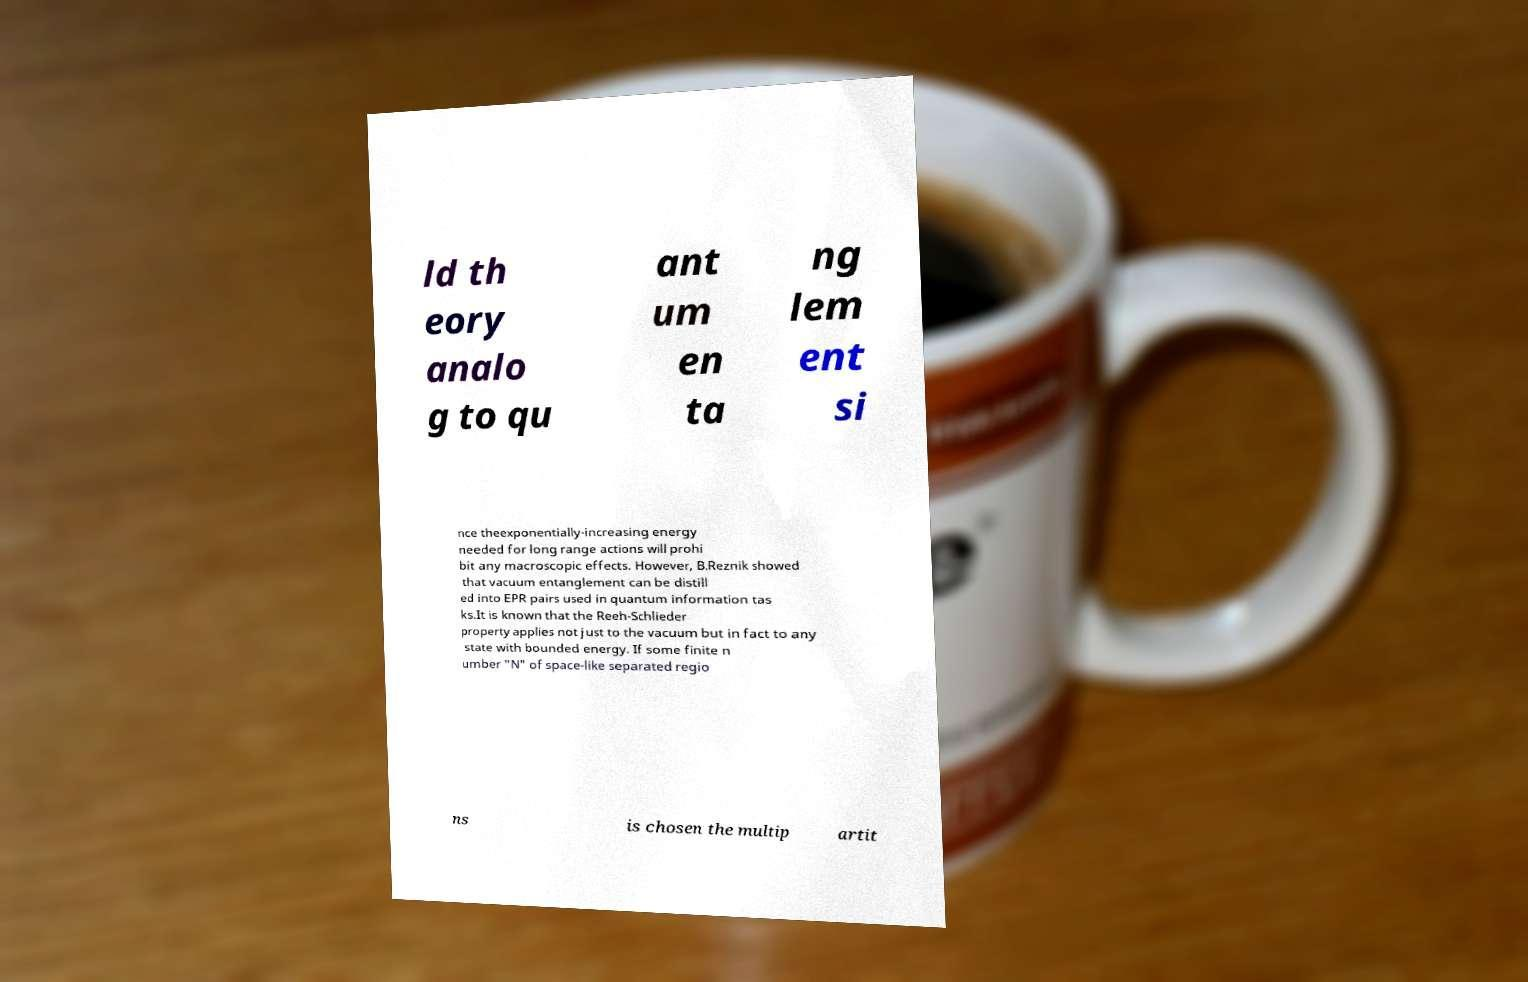There's text embedded in this image that I need extracted. Can you transcribe it verbatim? ld th eory analo g to qu ant um en ta ng lem ent si nce theexponentially-increasing energy needed for long range actions will prohi bit any macroscopic effects. However, B.Reznik showed that vacuum entanglement can be distill ed into EPR pairs used in quantum information tas ks.It is known that the Reeh-Schlieder property applies not just to the vacuum but in fact to any state with bounded energy. If some finite n umber "N" of space-like separated regio ns is chosen the multip artit 